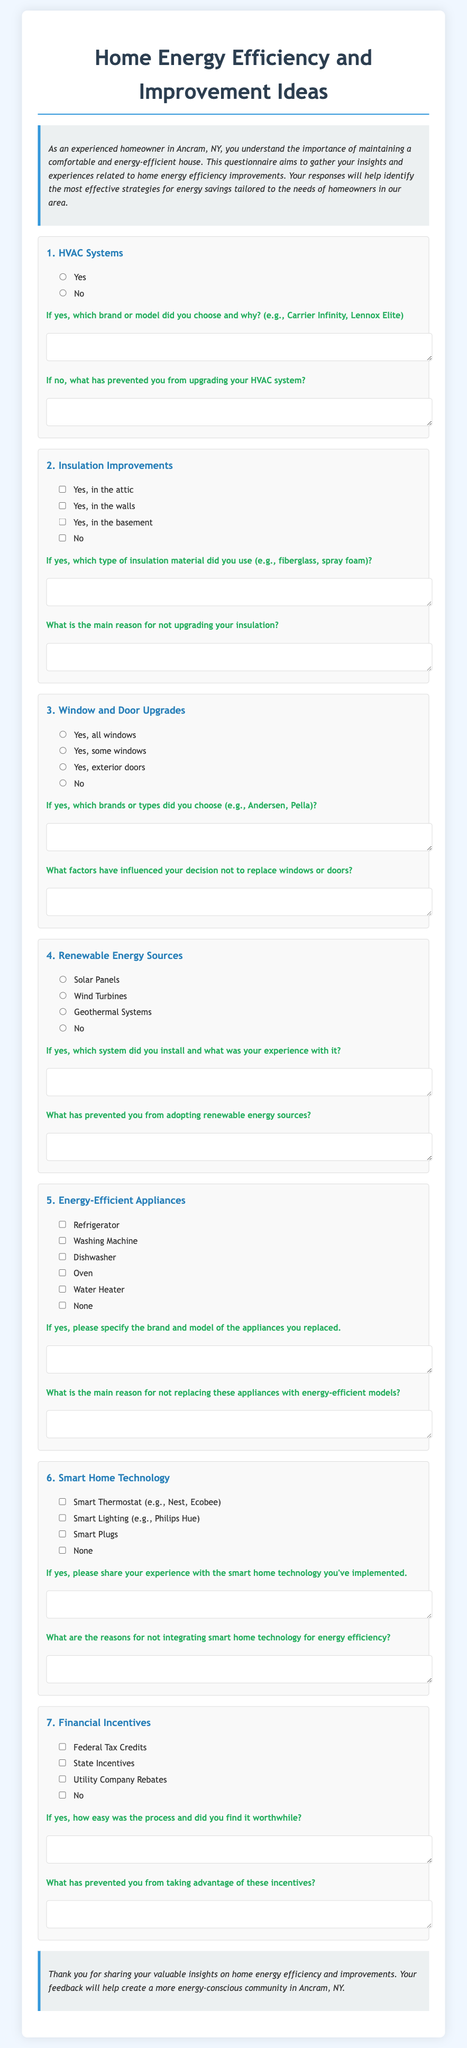What is the title of the questionnaire? The title is given at the top of the document, prominently displayed.
Answer: Home Energy Efficiency and Improvement Ideas How many main questions are in the document? The document contains a series of questions related to home energy efficiency, including HVAC, insulation, and more.
Answer: 7 Which input type is used for selecting energy-efficient appliances? The document specifies the input method for energy-efficient appliances as checkboxes.
Answer: Checkbox What is one example of a renewable energy source mentioned? The document lists options for renewable energy sources in one of the questions.
Answer: Solar Panels What is the main purpose of the questionnaire? The introductory paragraph provides insight into the intent behind gathering homeowner feedback.
Answer: To gather insights and experiences related to home energy efficiency improvements What should respondents specify about their HVAC system if they answered yes? The follow-up question requires details about their HVAC system choice and reasoning.
Answer: Brand or model chosen and why What aspect of home improvement does the conclusion section emphasize? The conclusion summarizes the impact of the responses collected through the questionnaire.
Answer: Create a more energy-conscious community 